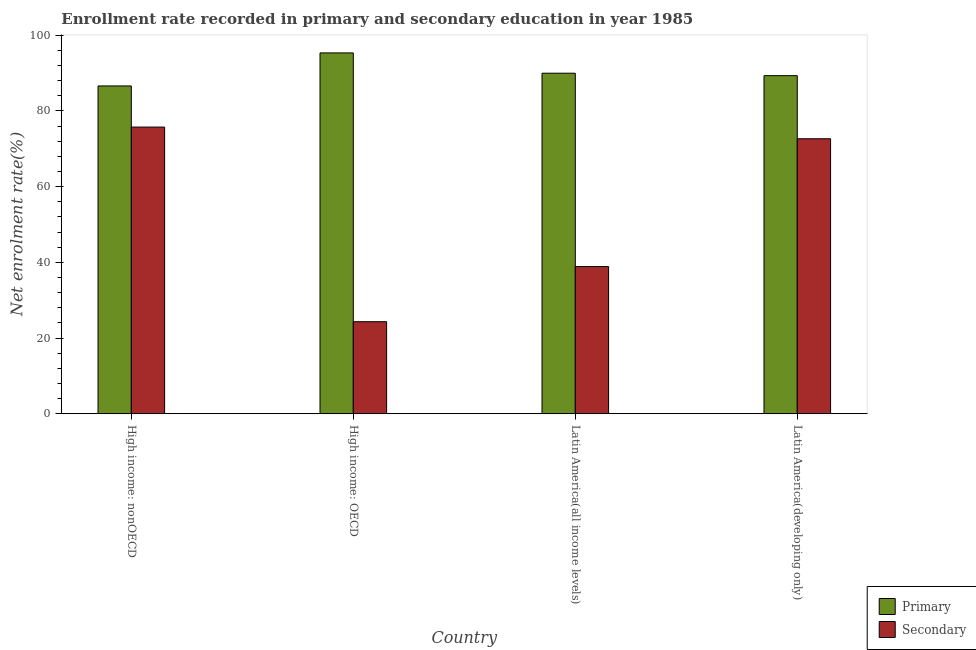How many different coloured bars are there?
Ensure brevity in your answer.  2. How many bars are there on the 1st tick from the right?
Keep it short and to the point. 2. What is the label of the 4th group of bars from the left?
Give a very brief answer. Latin America(developing only). In how many cases, is the number of bars for a given country not equal to the number of legend labels?
Your answer should be compact. 0. What is the enrollment rate in primary education in Latin America(developing only)?
Your response must be concise. 89.32. Across all countries, what is the maximum enrollment rate in secondary education?
Your answer should be very brief. 75.74. Across all countries, what is the minimum enrollment rate in primary education?
Give a very brief answer. 86.6. In which country was the enrollment rate in secondary education maximum?
Ensure brevity in your answer.  High income: nonOECD. In which country was the enrollment rate in primary education minimum?
Provide a succinct answer. High income: nonOECD. What is the total enrollment rate in primary education in the graph?
Offer a very short reply. 361.23. What is the difference between the enrollment rate in primary education in High income: nonOECD and that in Latin America(developing only)?
Your response must be concise. -2.72. What is the difference between the enrollment rate in secondary education in Latin America(developing only) and the enrollment rate in primary education in High income: nonOECD?
Ensure brevity in your answer.  -13.95. What is the average enrollment rate in secondary education per country?
Your answer should be compact. 52.9. What is the difference between the enrollment rate in secondary education and enrollment rate in primary education in Latin America(all income levels)?
Provide a short and direct response. -51.09. In how many countries, is the enrollment rate in primary education greater than 8 %?
Keep it short and to the point. 4. What is the ratio of the enrollment rate in secondary education in High income: nonOECD to that in Latin America(developing only)?
Make the answer very short. 1.04. Is the difference between the enrollment rate in primary education in Latin America(all income levels) and Latin America(developing only) greater than the difference between the enrollment rate in secondary education in Latin America(all income levels) and Latin America(developing only)?
Provide a succinct answer. Yes. What is the difference between the highest and the second highest enrollment rate in primary education?
Offer a terse response. 5.36. What is the difference between the highest and the lowest enrollment rate in secondary education?
Your response must be concise. 51.42. In how many countries, is the enrollment rate in primary education greater than the average enrollment rate in primary education taken over all countries?
Provide a succinct answer. 1. Is the sum of the enrollment rate in primary education in Latin America(all income levels) and Latin America(developing only) greater than the maximum enrollment rate in secondary education across all countries?
Make the answer very short. Yes. What does the 1st bar from the left in Latin America(developing only) represents?
Your answer should be very brief. Primary. What does the 2nd bar from the right in Latin America(all income levels) represents?
Provide a short and direct response. Primary. How many bars are there?
Give a very brief answer. 8. Are all the bars in the graph horizontal?
Your response must be concise. No. How many countries are there in the graph?
Offer a terse response. 4. What is the difference between two consecutive major ticks on the Y-axis?
Ensure brevity in your answer.  20. Are the values on the major ticks of Y-axis written in scientific E-notation?
Provide a short and direct response. No. Where does the legend appear in the graph?
Make the answer very short. Bottom right. How many legend labels are there?
Your answer should be very brief. 2. What is the title of the graph?
Offer a very short reply. Enrollment rate recorded in primary and secondary education in year 1985. Does "Private consumption" appear as one of the legend labels in the graph?
Make the answer very short. No. What is the label or title of the X-axis?
Provide a short and direct response. Country. What is the label or title of the Y-axis?
Your answer should be very brief. Net enrolment rate(%). What is the Net enrolment rate(%) of Primary in High income: nonOECD?
Provide a succinct answer. 86.6. What is the Net enrolment rate(%) in Secondary in High income: nonOECD?
Give a very brief answer. 75.74. What is the Net enrolment rate(%) of Primary in High income: OECD?
Make the answer very short. 95.33. What is the Net enrolment rate(%) of Secondary in High income: OECD?
Offer a very short reply. 24.32. What is the Net enrolment rate(%) in Primary in Latin America(all income levels)?
Offer a very short reply. 89.97. What is the Net enrolment rate(%) in Secondary in Latin America(all income levels)?
Keep it short and to the point. 38.88. What is the Net enrolment rate(%) of Primary in Latin America(developing only)?
Provide a succinct answer. 89.32. What is the Net enrolment rate(%) in Secondary in Latin America(developing only)?
Offer a very short reply. 72.65. Across all countries, what is the maximum Net enrolment rate(%) of Primary?
Provide a short and direct response. 95.33. Across all countries, what is the maximum Net enrolment rate(%) in Secondary?
Ensure brevity in your answer.  75.74. Across all countries, what is the minimum Net enrolment rate(%) of Primary?
Provide a short and direct response. 86.6. Across all countries, what is the minimum Net enrolment rate(%) in Secondary?
Give a very brief answer. 24.32. What is the total Net enrolment rate(%) of Primary in the graph?
Your answer should be very brief. 361.23. What is the total Net enrolment rate(%) of Secondary in the graph?
Ensure brevity in your answer.  211.59. What is the difference between the Net enrolment rate(%) of Primary in High income: nonOECD and that in High income: OECD?
Make the answer very short. -8.73. What is the difference between the Net enrolment rate(%) of Secondary in High income: nonOECD and that in High income: OECD?
Keep it short and to the point. 51.42. What is the difference between the Net enrolment rate(%) of Primary in High income: nonOECD and that in Latin America(all income levels)?
Provide a succinct answer. -3.37. What is the difference between the Net enrolment rate(%) of Secondary in High income: nonOECD and that in Latin America(all income levels)?
Provide a short and direct response. 36.86. What is the difference between the Net enrolment rate(%) of Primary in High income: nonOECD and that in Latin America(developing only)?
Your answer should be compact. -2.72. What is the difference between the Net enrolment rate(%) of Secondary in High income: nonOECD and that in Latin America(developing only)?
Make the answer very short. 3.09. What is the difference between the Net enrolment rate(%) in Primary in High income: OECD and that in Latin America(all income levels)?
Offer a very short reply. 5.36. What is the difference between the Net enrolment rate(%) in Secondary in High income: OECD and that in Latin America(all income levels)?
Keep it short and to the point. -14.56. What is the difference between the Net enrolment rate(%) in Primary in High income: OECD and that in Latin America(developing only)?
Your response must be concise. 6.01. What is the difference between the Net enrolment rate(%) of Secondary in High income: OECD and that in Latin America(developing only)?
Offer a very short reply. -48.33. What is the difference between the Net enrolment rate(%) of Primary in Latin America(all income levels) and that in Latin America(developing only)?
Provide a succinct answer. 0.65. What is the difference between the Net enrolment rate(%) of Secondary in Latin America(all income levels) and that in Latin America(developing only)?
Provide a succinct answer. -33.77. What is the difference between the Net enrolment rate(%) of Primary in High income: nonOECD and the Net enrolment rate(%) of Secondary in High income: OECD?
Your response must be concise. 62.28. What is the difference between the Net enrolment rate(%) in Primary in High income: nonOECD and the Net enrolment rate(%) in Secondary in Latin America(all income levels)?
Make the answer very short. 47.73. What is the difference between the Net enrolment rate(%) of Primary in High income: nonOECD and the Net enrolment rate(%) of Secondary in Latin America(developing only)?
Give a very brief answer. 13.95. What is the difference between the Net enrolment rate(%) in Primary in High income: OECD and the Net enrolment rate(%) in Secondary in Latin America(all income levels)?
Provide a succinct answer. 56.45. What is the difference between the Net enrolment rate(%) in Primary in High income: OECD and the Net enrolment rate(%) in Secondary in Latin America(developing only)?
Give a very brief answer. 22.68. What is the difference between the Net enrolment rate(%) of Primary in Latin America(all income levels) and the Net enrolment rate(%) of Secondary in Latin America(developing only)?
Make the answer very short. 17.32. What is the average Net enrolment rate(%) in Primary per country?
Give a very brief answer. 90.31. What is the average Net enrolment rate(%) in Secondary per country?
Your answer should be very brief. 52.9. What is the difference between the Net enrolment rate(%) in Primary and Net enrolment rate(%) in Secondary in High income: nonOECD?
Ensure brevity in your answer.  10.87. What is the difference between the Net enrolment rate(%) in Primary and Net enrolment rate(%) in Secondary in High income: OECD?
Your answer should be compact. 71.01. What is the difference between the Net enrolment rate(%) in Primary and Net enrolment rate(%) in Secondary in Latin America(all income levels)?
Provide a succinct answer. 51.09. What is the difference between the Net enrolment rate(%) of Primary and Net enrolment rate(%) of Secondary in Latin America(developing only)?
Provide a succinct answer. 16.67. What is the ratio of the Net enrolment rate(%) in Primary in High income: nonOECD to that in High income: OECD?
Ensure brevity in your answer.  0.91. What is the ratio of the Net enrolment rate(%) in Secondary in High income: nonOECD to that in High income: OECD?
Keep it short and to the point. 3.11. What is the ratio of the Net enrolment rate(%) in Primary in High income: nonOECD to that in Latin America(all income levels)?
Provide a short and direct response. 0.96. What is the ratio of the Net enrolment rate(%) in Secondary in High income: nonOECD to that in Latin America(all income levels)?
Your response must be concise. 1.95. What is the ratio of the Net enrolment rate(%) in Primary in High income: nonOECD to that in Latin America(developing only)?
Offer a very short reply. 0.97. What is the ratio of the Net enrolment rate(%) in Secondary in High income: nonOECD to that in Latin America(developing only)?
Ensure brevity in your answer.  1.04. What is the ratio of the Net enrolment rate(%) in Primary in High income: OECD to that in Latin America(all income levels)?
Offer a very short reply. 1.06. What is the ratio of the Net enrolment rate(%) in Secondary in High income: OECD to that in Latin America(all income levels)?
Make the answer very short. 0.63. What is the ratio of the Net enrolment rate(%) in Primary in High income: OECD to that in Latin America(developing only)?
Give a very brief answer. 1.07. What is the ratio of the Net enrolment rate(%) of Secondary in High income: OECD to that in Latin America(developing only)?
Keep it short and to the point. 0.33. What is the ratio of the Net enrolment rate(%) in Primary in Latin America(all income levels) to that in Latin America(developing only)?
Ensure brevity in your answer.  1.01. What is the ratio of the Net enrolment rate(%) in Secondary in Latin America(all income levels) to that in Latin America(developing only)?
Provide a short and direct response. 0.54. What is the difference between the highest and the second highest Net enrolment rate(%) of Primary?
Keep it short and to the point. 5.36. What is the difference between the highest and the second highest Net enrolment rate(%) in Secondary?
Your answer should be very brief. 3.09. What is the difference between the highest and the lowest Net enrolment rate(%) in Primary?
Keep it short and to the point. 8.73. What is the difference between the highest and the lowest Net enrolment rate(%) of Secondary?
Give a very brief answer. 51.42. 